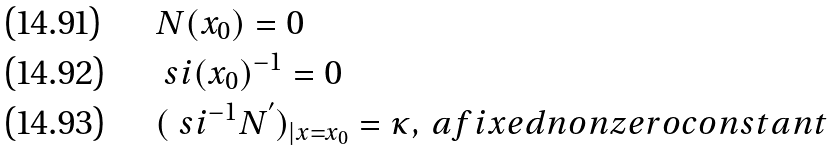Convert formula to latex. <formula><loc_0><loc_0><loc_500><loc_500>& N ( x _ { 0 } ) = 0 \\ & \ s i ( x _ { 0 } ) ^ { - 1 } = 0 \\ & ( \ s i ^ { - 1 } N ^ { ^ { \prime } } ) _ { | x = x _ { 0 } } = \kappa , \, a f i x e d n o n z e r o c o n s t a n t</formula> 